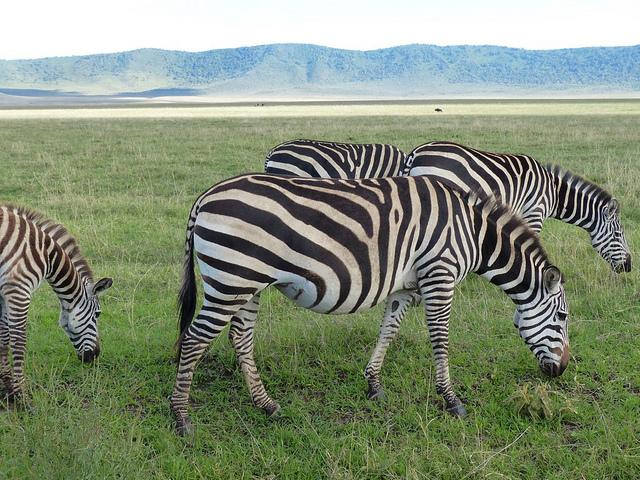Are the zebras in captivity?
Keep it brief. No. Are the zebras vegetarians?
Be succinct. Yes. What landforms are in the background of this picture?
Short answer required. Mountains. 